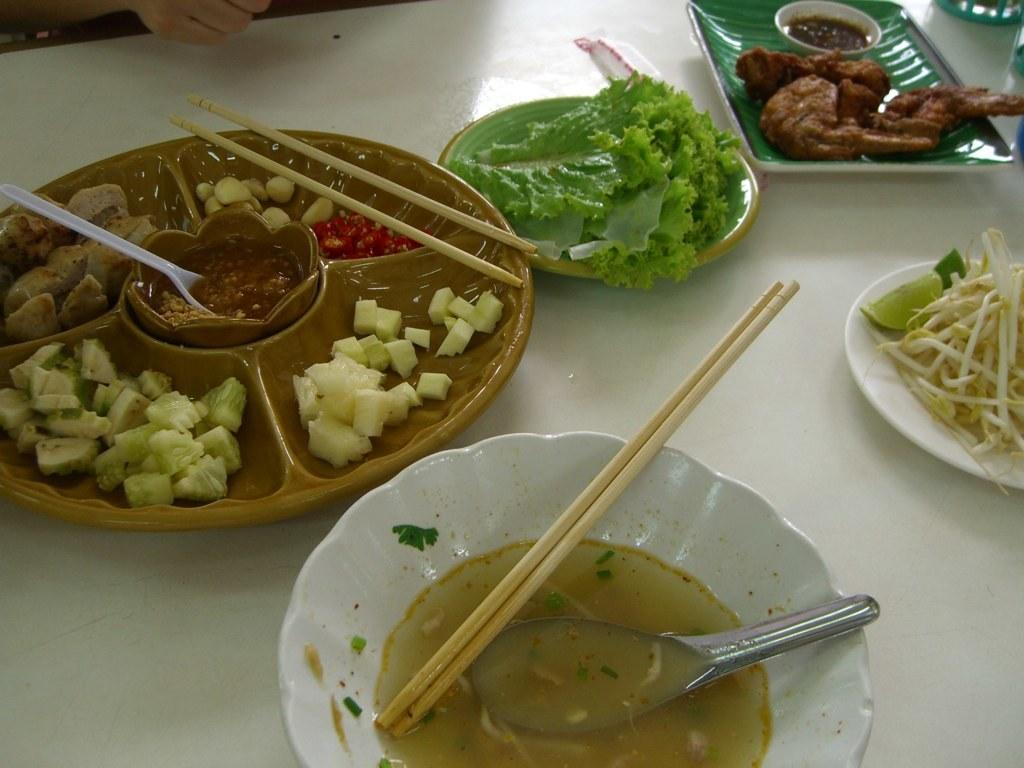What type of utensils can be seen in the image? There are chopsticks and spoons in the image. What else is present in the image besides utensils? There are plates, a small bowl, and food items on the plates. What is the color of the object that the plates are placed on? The plates are on a white object. What type of pet can be seen playing with a bar of soap in the image? There is no pet or soap present in the image. What color is the ink used for writing on the plates in the image? There is no ink or writing on the plates in the image. 